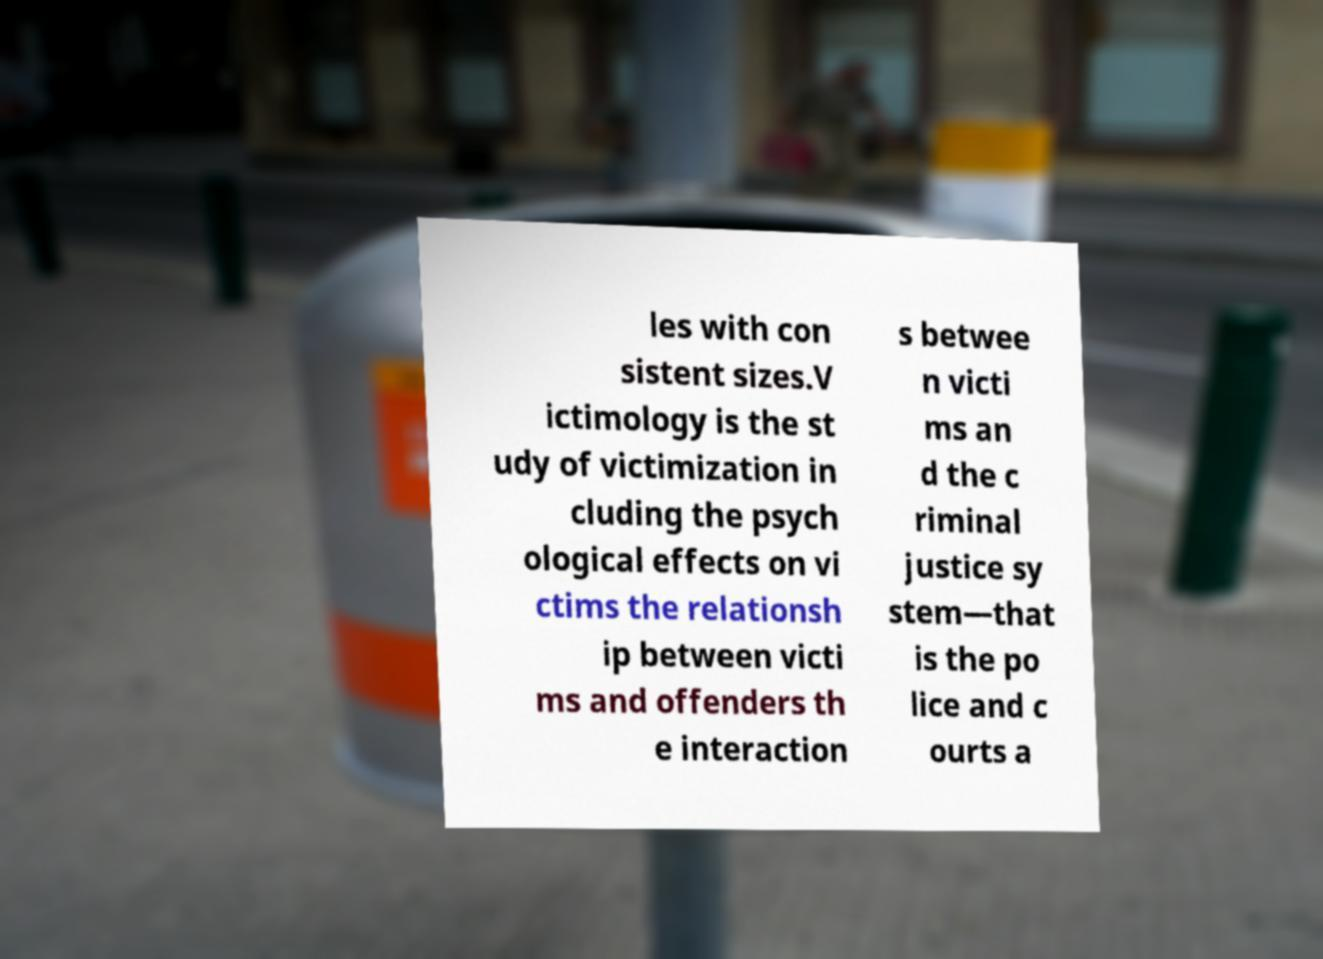Can you read and provide the text displayed in the image?This photo seems to have some interesting text. Can you extract and type it out for me? les with con sistent sizes.V ictimology is the st udy of victimization in cluding the psych ological effects on vi ctims the relationsh ip between victi ms and offenders th e interaction s betwee n victi ms an d the c riminal justice sy stem—that is the po lice and c ourts a 